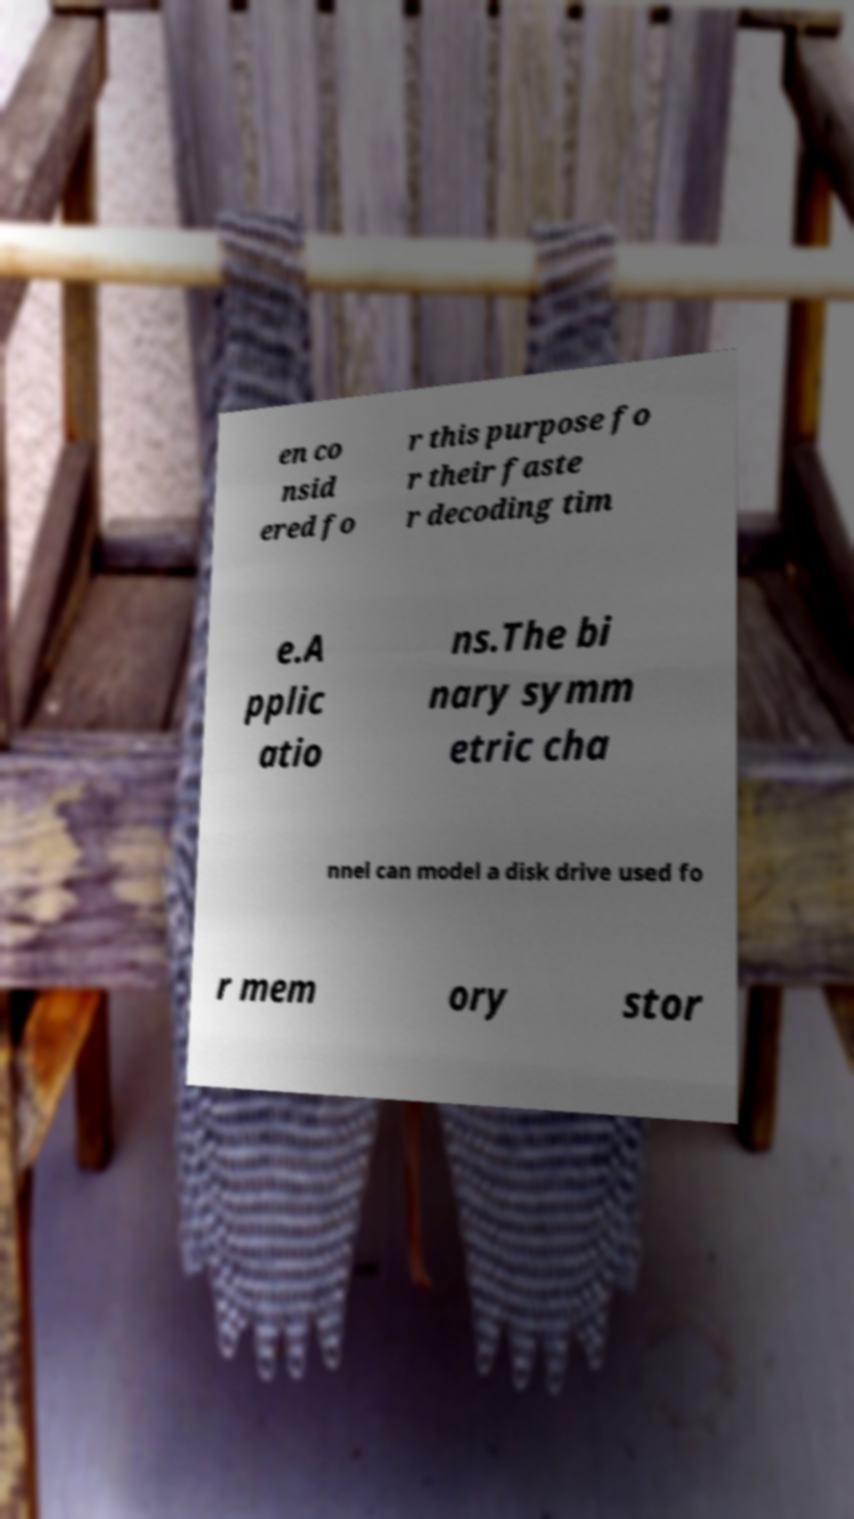I need the written content from this picture converted into text. Can you do that? en co nsid ered fo r this purpose fo r their faste r decoding tim e.A pplic atio ns.The bi nary symm etric cha nnel can model a disk drive used fo r mem ory stor 